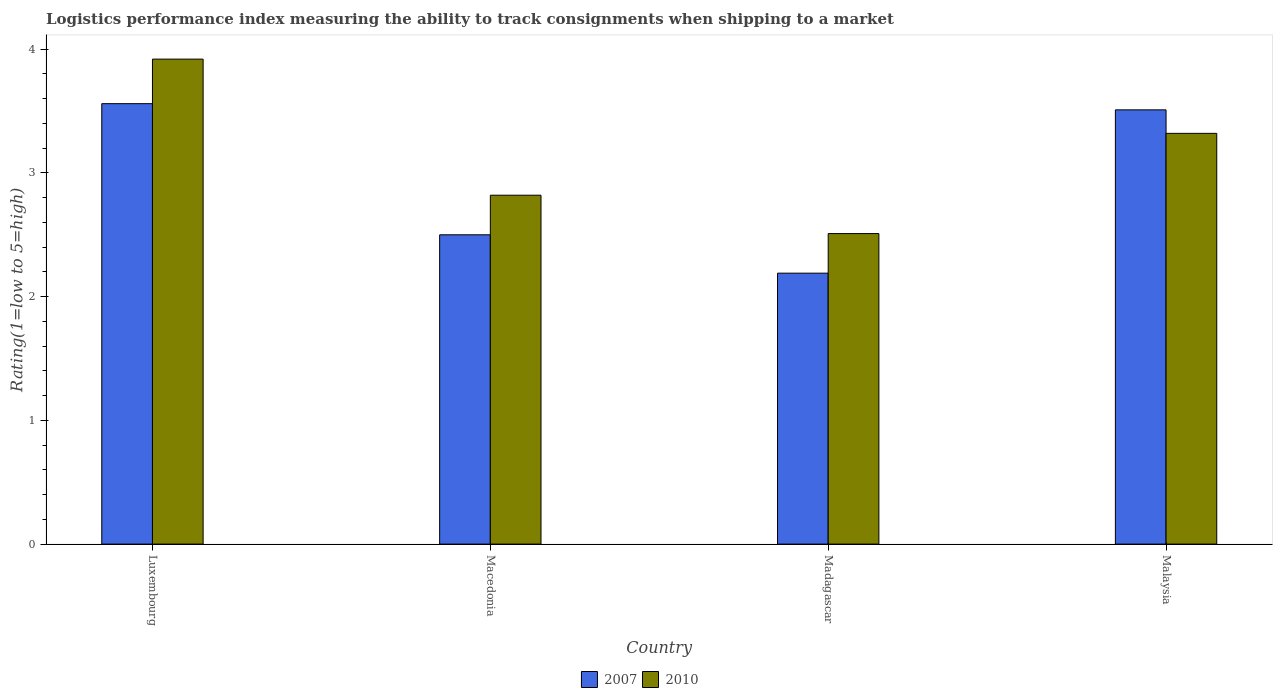How many groups of bars are there?
Ensure brevity in your answer.  4. Are the number of bars per tick equal to the number of legend labels?
Provide a succinct answer. Yes. Are the number of bars on each tick of the X-axis equal?
Give a very brief answer. Yes. How many bars are there on the 3rd tick from the right?
Give a very brief answer. 2. What is the label of the 3rd group of bars from the left?
Offer a very short reply. Madagascar. What is the Logistic performance index in 2007 in Luxembourg?
Ensure brevity in your answer.  3.56. Across all countries, what is the maximum Logistic performance index in 2010?
Your answer should be compact. 3.92. Across all countries, what is the minimum Logistic performance index in 2010?
Keep it short and to the point. 2.51. In which country was the Logistic performance index in 2007 maximum?
Provide a succinct answer. Luxembourg. In which country was the Logistic performance index in 2007 minimum?
Make the answer very short. Madagascar. What is the total Logistic performance index in 2007 in the graph?
Your response must be concise. 11.76. What is the difference between the Logistic performance index in 2010 in Macedonia and that in Madagascar?
Give a very brief answer. 0.31. What is the difference between the Logistic performance index in 2007 in Luxembourg and the Logistic performance index in 2010 in Malaysia?
Offer a terse response. 0.24. What is the average Logistic performance index in 2010 per country?
Provide a succinct answer. 3.14. What is the difference between the Logistic performance index of/in 2010 and Logistic performance index of/in 2007 in Macedonia?
Keep it short and to the point. 0.32. What is the ratio of the Logistic performance index in 2010 in Macedonia to that in Madagascar?
Provide a succinct answer. 1.12. Is the difference between the Logistic performance index in 2010 in Macedonia and Madagascar greater than the difference between the Logistic performance index in 2007 in Macedonia and Madagascar?
Keep it short and to the point. No. What is the difference between the highest and the second highest Logistic performance index in 2010?
Make the answer very short. 0.5. What is the difference between the highest and the lowest Logistic performance index in 2007?
Your answer should be compact. 1.37. Are all the bars in the graph horizontal?
Ensure brevity in your answer.  No. What is the difference between two consecutive major ticks on the Y-axis?
Your answer should be very brief. 1. Are the values on the major ticks of Y-axis written in scientific E-notation?
Your answer should be compact. No. Does the graph contain any zero values?
Give a very brief answer. No. Does the graph contain grids?
Keep it short and to the point. No. Where does the legend appear in the graph?
Provide a short and direct response. Bottom center. How are the legend labels stacked?
Make the answer very short. Horizontal. What is the title of the graph?
Your response must be concise. Logistics performance index measuring the ability to track consignments when shipping to a market. What is the label or title of the X-axis?
Your response must be concise. Country. What is the label or title of the Y-axis?
Provide a short and direct response. Rating(1=low to 5=high). What is the Rating(1=low to 5=high) of 2007 in Luxembourg?
Your response must be concise. 3.56. What is the Rating(1=low to 5=high) of 2010 in Luxembourg?
Provide a succinct answer. 3.92. What is the Rating(1=low to 5=high) in 2007 in Macedonia?
Give a very brief answer. 2.5. What is the Rating(1=low to 5=high) in 2010 in Macedonia?
Your response must be concise. 2.82. What is the Rating(1=low to 5=high) in 2007 in Madagascar?
Offer a terse response. 2.19. What is the Rating(1=low to 5=high) in 2010 in Madagascar?
Keep it short and to the point. 2.51. What is the Rating(1=low to 5=high) in 2007 in Malaysia?
Keep it short and to the point. 3.51. What is the Rating(1=low to 5=high) of 2010 in Malaysia?
Offer a very short reply. 3.32. Across all countries, what is the maximum Rating(1=low to 5=high) in 2007?
Provide a succinct answer. 3.56. Across all countries, what is the maximum Rating(1=low to 5=high) of 2010?
Give a very brief answer. 3.92. Across all countries, what is the minimum Rating(1=low to 5=high) of 2007?
Your answer should be compact. 2.19. Across all countries, what is the minimum Rating(1=low to 5=high) of 2010?
Ensure brevity in your answer.  2.51. What is the total Rating(1=low to 5=high) of 2007 in the graph?
Ensure brevity in your answer.  11.76. What is the total Rating(1=low to 5=high) of 2010 in the graph?
Provide a succinct answer. 12.57. What is the difference between the Rating(1=low to 5=high) in 2007 in Luxembourg and that in Macedonia?
Keep it short and to the point. 1.06. What is the difference between the Rating(1=low to 5=high) in 2010 in Luxembourg and that in Macedonia?
Your answer should be very brief. 1.1. What is the difference between the Rating(1=low to 5=high) of 2007 in Luxembourg and that in Madagascar?
Make the answer very short. 1.37. What is the difference between the Rating(1=low to 5=high) of 2010 in Luxembourg and that in Madagascar?
Offer a terse response. 1.41. What is the difference between the Rating(1=low to 5=high) of 2007 in Luxembourg and that in Malaysia?
Your answer should be compact. 0.05. What is the difference between the Rating(1=low to 5=high) in 2010 in Luxembourg and that in Malaysia?
Offer a terse response. 0.6. What is the difference between the Rating(1=low to 5=high) in 2007 in Macedonia and that in Madagascar?
Give a very brief answer. 0.31. What is the difference between the Rating(1=low to 5=high) of 2010 in Macedonia and that in Madagascar?
Provide a succinct answer. 0.31. What is the difference between the Rating(1=low to 5=high) of 2007 in Macedonia and that in Malaysia?
Provide a succinct answer. -1.01. What is the difference between the Rating(1=low to 5=high) in 2007 in Madagascar and that in Malaysia?
Your answer should be compact. -1.32. What is the difference between the Rating(1=low to 5=high) of 2010 in Madagascar and that in Malaysia?
Keep it short and to the point. -0.81. What is the difference between the Rating(1=low to 5=high) in 2007 in Luxembourg and the Rating(1=low to 5=high) in 2010 in Macedonia?
Ensure brevity in your answer.  0.74. What is the difference between the Rating(1=low to 5=high) of 2007 in Luxembourg and the Rating(1=low to 5=high) of 2010 in Malaysia?
Ensure brevity in your answer.  0.24. What is the difference between the Rating(1=low to 5=high) in 2007 in Macedonia and the Rating(1=low to 5=high) in 2010 in Madagascar?
Ensure brevity in your answer.  -0.01. What is the difference between the Rating(1=low to 5=high) of 2007 in Macedonia and the Rating(1=low to 5=high) of 2010 in Malaysia?
Ensure brevity in your answer.  -0.82. What is the difference between the Rating(1=low to 5=high) in 2007 in Madagascar and the Rating(1=low to 5=high) in 2010 in Malaysia?
Your answer should be very brief. -1.13. What is the average Rating(1=low to 5=high) of 2007 per country?
Your answer should be very brief. 2.94. What is the average Rating(1=low to 5=high) of 2010 per country?
Your answer should be very brief. 3.14. What is the difference between the Rating(1=low to 5=high) of 2007 and Rating(1=low to 5=high) of 2010 in Luxembourg?
Offer a very short reply. -0.36. What is the difference between the Rating(1=low to 5=high) in 2007 and Rating(1=low to 5=high) in 2010 in Macedonia?
Keep it short and to the point. -0.32. What is the difference between the Rating(1=low to 5=high) in 2007 and Rating(1=low to 5=high) in 2010 in Madagascar?
Provide a short and direct response. -0.32. What is the difference between the Rating(1=low to 5=high) of 2007 and Rating(1=low to 5=high) of 2010 in Malaysia?
Offer a very short reply. 0.19. What is the ratio of the Rating(1=low to 5=high) of 2007 in Luxembourg to that in Macedonia?
Offer a very short reply. 1.42. What is the ratio of the Rating(1=low to 5=high) of 2010 in Luxembourg to that in Macedonia?
Your response must be concise. 1.39. What is the ratio of the Rating(1=low to 5=high) of 2007 in Luxembourg to that in Madagascar?
Give a very brief answer. 1.63. What is the ratio of the Rating(1=low to 5=high) in 2010 in Luxembourg to that in Madagascar?
Provide a succinct answer. 1.56. What is the ratio of the Rating(1=low to 5=high) of 2007 in Luxembourg to that in Malaysia?
Your answer should be very brief. 1.01. What is the ratio of the Rating(1=low to 5=high) in 2010 in Luxembourg to that in Malaysia?
Provide a short and direct response. 1.18. What is the ratio of the Rating(1=low to 5=high) of 2007 in Macedonia to that in Madagascar?
Keep it short and to the point. 1.14. What is the ratio of the Rating(1=low to 5=high) of 2010 in Macedonia to that in Madagascar?
Your answer should be compact. 1.12. What is the ratio of the Rating(1=low to 5=high) in 2007 in Macedonia to that in Malaysia?
Make the answer very short. 0.71. What is the ratio of the Rating(1=low to 5=high) of 2010 in Macedonia to that in Malaysia?
Keep it short and to the point. 0.85. What is the ratio of the Rating(1=low to 5=high) of 2007 in Madagascar to that in Malaysia?
Make the answer very short. 0.62. What is the ratio of the Rating(1=low to 5=high) of 2010 in Madagascar to that in Malaysia?
Keep it short and to the point. 0.76. What is the difference between the highest and the second highest Rating(1=low to 5=high) of 2007?
Provide a short and direct response. 0.05. What is the difference between the highest and the second highest Rating(1=low to 5=high) of 2010?
Your answer should be compact. 0.6. What is the difference between the highest and the lowest Rating(1=low to 5=high) in 2007?
Give a very brief answer. 1.37. What is the difference between the highest and the lowest Rating(1=low to 5=high) in 2010?
Keep it short and to the point. 1.41. 